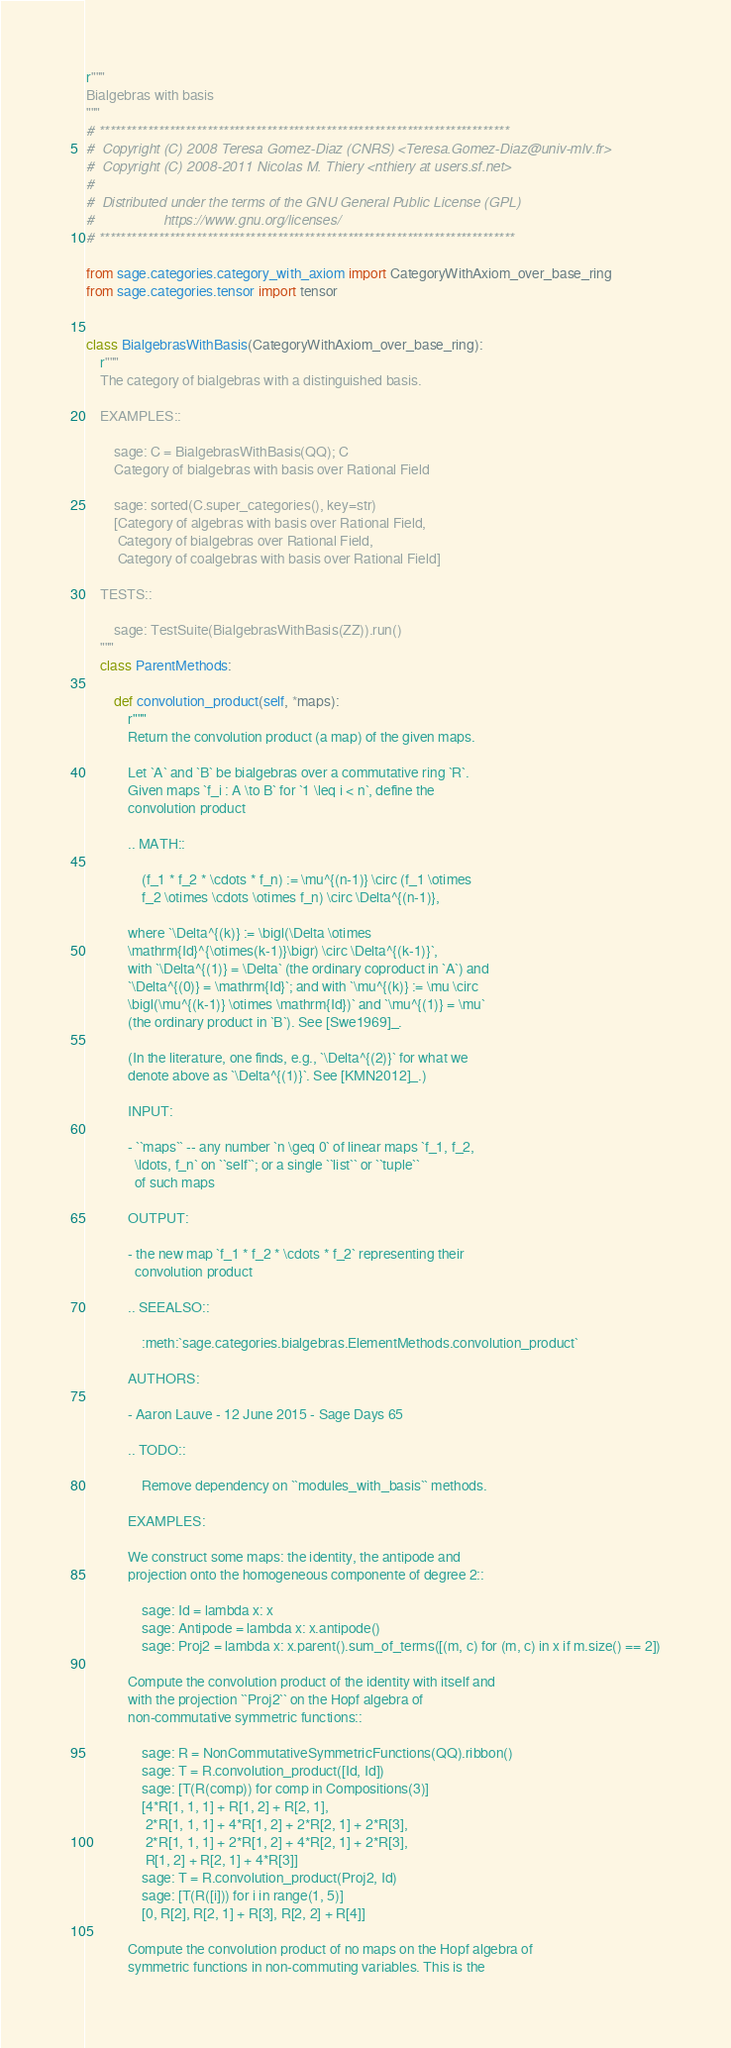<code> <loc_0><loc_0><loc_500><loc_500><_Python_>r"""
Bialgebras with basis
"""
# ****************************************************************************
#  Copyright (C) 2008 Teresa Gomez-Diaz (CNRS) <Teresa.Gomez-Diaz@univ-mlv.fr>
#  Copyright (C) 2008-2011 Nicolas M. Thiery <nthiery at users.sf.net>
#
#  Distributed under the terms of the GNU General Public License (GPL)
#                  https://www.gnu.org/licenses/
# *****************************************************************************

from sage.categories.category_with_axiom import CategoryWithAxiom_over_base_ring
from sage.categories.tensor import tensor


class BialgebrasWithBasis(CategoryWithAxiom_over_base_ring):
    r"""
    The category of bialgebras with a distinguished basis.

    EXAMPLES::

        sage: C = BialgebrasWithBasis(QQ); C
        Category of bialgebras with basis over Rational Field

        sage: sorted(C.super_categories(), key=str)
        [Category of algebras with basis over Rational Field,
         Category of bialgebras over Rational Field,
         Category of coalgebras with basis over Rational Field]

    TESTS::

        sage: TestSuite(BialgebrasWithBasis(ZZ)).run()
    """
    class ParentMethods:

        def convolution_product(self, *maps):
            r"""
            Return the convolution product (a map) of the given maps.

            Let `A` and `B` be bialgebras over a commutative ring `R`.
            Given maps `f_i : A \to B` for `1 \leq i < n`, define the
            convolution product

            .. MATH::

                (f_1 * f_2 * \cdots * f_n) := \mu^{(n-1)} \circ (f_1 \otimes
                f_2 \otimes \cdots \otimes f_n) \circ \Delta^{(n-1)},

            where `\Delta^{(k)} := \bigl(\Delta \otimes
            \mathrm{Id}^{\otimes(k-1)}\bigr) \circ \Delta^{(k-1)}`,
            with `\Delta^{(1)} = \Delta` (the ordinary coproduct in `A`) and
            `\Delta^{(0)} = \mathrm{Id}`; and with `\mu^{(k)} := \mu \circ
            \bigl(\mu^{(k-1)} \otimes \mathrm{Id})` and `\mu^{(1)} = \mu`
            (the ordinary product in `B`). See [Swe1969]_.

            (In the literature, one finds, e.g., `\Delta^{(2)}` for what we
            denote above as `\Delta^{(1)}`. See [KMN2012]_.)

            INPUT:

            - ``maps`` -- any number `n \geq 0` of linear maps `f_1, f_2,
              \ldots, f_n` on ``self``; or a single ``list`` or ``tuple``
              of such maps

            OUTPUT:

            - the new map `f_1 * f_2 * \cdots * f_2` representing their
              convolution product

            .. SEEALSO::

                :meth:`sage.categories.bialgebras.ElementMethods.convolution_product`

            AUTHORS:

            - Aaron Lauve - 12 June 2015 - Sage Days 65

            .. TODO::

                Remove dependency on ``modules_with_basis`` methods.

            EXAMPLES:

            We construct some maps: the identity, the antipode and
            projection onto the homogeneous componente of degree 2::

                sage: Id = lambda x: x
                sage: Antipode = lambda x: x.antipode()
                sage: Proj2 = lambda x: x.parent().sum_of_terms([(m, c) for (m, c) in x if m.size() == 2])

            Compute the convolution product of the identity with itself and
            with the projection ``Proj2`` on the Hopf algebra of
            non-commutative symmetric functions::

                sage: R = NonCommutativeSymmetricFunctions(QQ).ribbon()
                sage: T = R.convolution_product([Id, Id])
                sage: [T(R(comp)) for comp in Compositions(3)]
                [4*R[1, 1, 1] + R[1, 2] + R[2, 1],
                 2*R[1, 1, 1] + 4*R[1, 2] + 2*R[2, 1] + 2*R[3],
                 2*R[1, 1, 1] + 2*R[1, 2] + 4*R[2, 1] + 2*R[3],
                 R[1, 2] + R[2, 1] + 4*R[3]]
                sage: T = R.convolution_product(Proj2, Id)
                sage: [T(R([i])) for i in range(1, 5)]
                [0, R[2], R[2, 1] + R[3], R[2, 2] + R[4]]

            Compute the convolution product of no maps on the Hopf algebra of
            symmetric functions in non-commuting variables. This is the</code> 